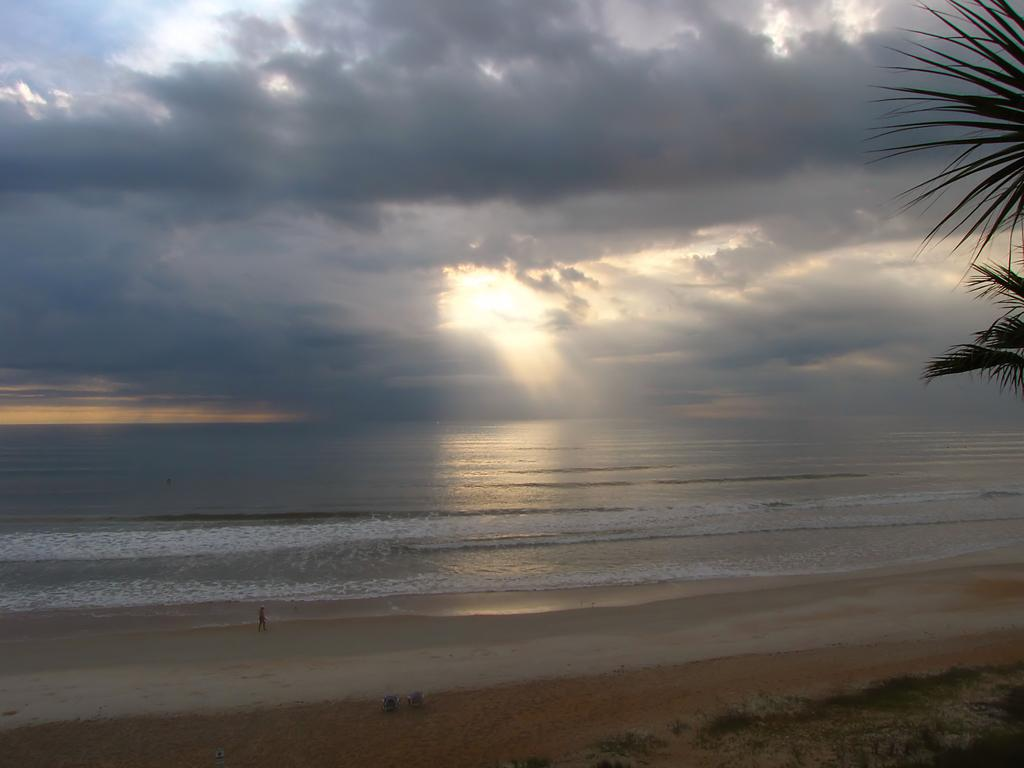What type of terrain is visible in the image? Ground and water are visible in the image. What type of vegetation is present in the image? There is a tree in the image. What is visible in the sky in the image? Clouds are visible in the sky in the image. Can the sky be seen in the image? Yes, the sky is visible in the image. What is the person in the image doing? There is a person standing in the image, but their activity is not specified. What type of yarn is being used by the society in the image? There is no mention of yarn or society in the image. The image features a person standing near a tree, ground, water, clouds, and sky. 